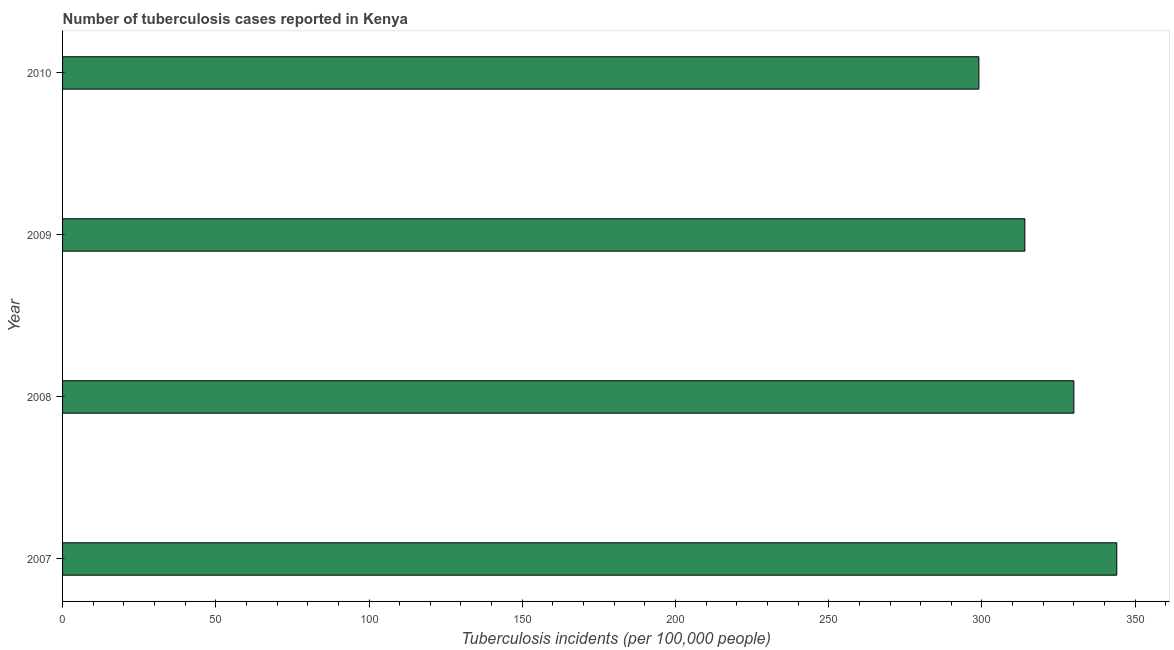What is the title of the graph?
Give a very brief answer. Number of tuberculosis cases reported in Kenya. What is the label or title of the X-axis?
Ensure brevity in your answer.  Tuberculosis incidents (per 100,0 people). What is the label or title of the Y-axis?
Offer a very short reply. Year. What is the number of tuberculosis incidents in 2010?
Ensure brevity in your answer.  299. Across all years, what is the maximum number of tuberculosis incidents?
Offer a terse response. 344. Across all years, what is the minimum number of tuberculosis incidents?
Make the answer very short. 299. In which year was the number of tuberculosis incidents minimum?
Keep it short and to the point. 2010. What is the sum of the number of tuberculosis incidents?
Your answer should be very brief. 1287. What is the difference between the number of tuberculosis incidents in 2008 and 2010?
Offer a terse response. 31. What is the average number of tuberculosis incidents per year?
Provide a short and direct response. 321. What is the median number of tuberculosis incidents?
Offer a very short reply. 322. In how many years, is the number of tuberculosis incidents greater than 270 ?
Offer a very short reply. 4. What is the ratio of the number of tuberculosis incidents in 2007 to that in 2008?
Offer a terse response. 1.04. Is the number of tuberculosis incidents in 2007 less than that in 2008?
Keep it short and to the point. No. Is the sum of the number of tuberculosis incidents in 2007 and 2008 greater than the maximum number of tuberculosis incidents across all years?
Offer a terse response. Yes. What is the difference between the highest and the lowest number of tuberculosis incidents?
Keep it short and to the point. 45. In how many years, is the number of tuberculosis incidents greater than the average number of tuberculosis incidents taken over all years?
Offer a terse response. 2. Are all the bars in the graph horizontal?
Your answer should be very brief. Yes. What is the Tuberculosis incidents (per 100,000 people) of 2007?
Your answer should be very brief. 344. What is the Tuberculosis incidents (per 100,000 people) of 2008?
Your answer should be very brief. 330. What is the Tuberculosis incidents (per 100,000 people) in 2009?
Your response must be concise. 314. What is the Tuberculosis incidents (per 100,000 people) in 2010?
Your answer should be very brief. 299. What is the difference between the Tuberculosis incidents (per 100,000 people) in 2007 and 2008?
Offer a very short reply. 14. What is the difference between the Tuberculosis incidents (per 100,000 people) in 2007 and 2009?
Provide a short and direct response. 30. What is the difference between the Tuberculosis incidents (per 100,000 people) in 2008 and 2010?
Your response must be concise. 31. What is the ratio of the Tuberculosis incidents (per 100,000 people) in 2007 to that in 2008?
Provide a succinct answer. 1.04. What is the ratio of the Tuberculosis incidents (per 100,000 people) in 2007 to that in 2009?
Make the answer very short. 1.1. What is the ratio of the Tuberculosis incidents (per 100,000 people) in 2007 to that in 2010?
Keep it short and to the point. 1.15. What is the ratio of the Tuberculosis incidents (per 100,000 people) in 2008 to that in 2009?
Ensure brevity in your answer.  1.05. What is the ratio of the Tuberculosis incidents (per 100,000 people) in 2008 to that in 2010?
Your response must be concise. 1.1. What is the ratio of the Tuberculosis incidents (per 100,000 people) in 2009 to that in 2010?
Provide a succinct answer. 1.05. 